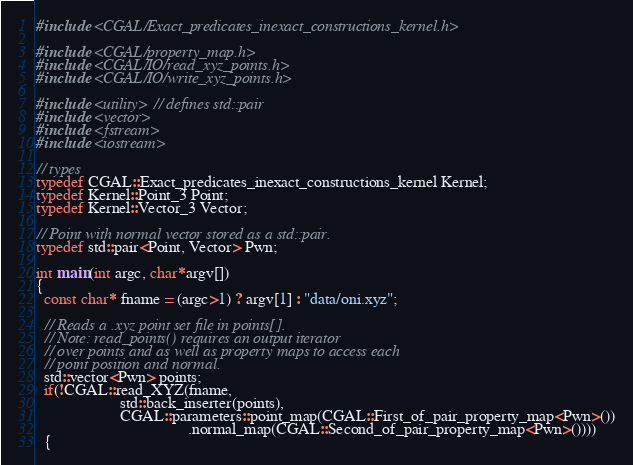<code> <loc_0><loc_0><loc_500><loc_500><_C++_>#include <CGAL/Exact_predicates_inexact_constructions_kernel.h>

#include <CGAL/property_map.h>
#include <CGAL/IO/read_xyz_points.h>
#include <CGAL/IO/write_xyz_points.h>

#include <utility> // defines std::pair
#include <vector>
#include <fstream>
#include <iostream>

// types
typedef CGAL::Exact_predicates_inexact_constructions_kernel Kernel;
typedef Kernel::Point_3 Point;
typedef Kernel::Vector_3 Vector;

// Point with normal vector stored as a std::pair.
typedef std::pair<Point, Vector> Pwn;

int main(int argc, char*argv[])
{
  const char* fname = (argc>1) ? argv[1] : "data/oni.xyz";

  // Reads a .xyz point set file in points[].
  // Note: read_points() requires an output iterator
  // over points and as well as property maps to access each
  // point position and normal.
  std::vector<Pwn> points;
  if(!CGAL::read_XYZ(fname,
                     std::back_inserter(points),
                     CGAL::parameters::point_map(CGAL::First_of_pair_property_map<Pwn>())
                                      .normal_map(CGAL::Second_of_pair_property_map<Pwn>())))
  {</code> 